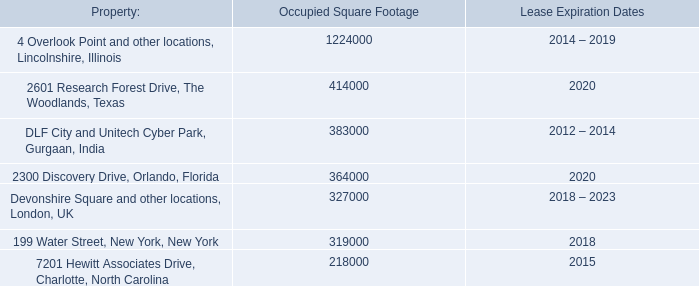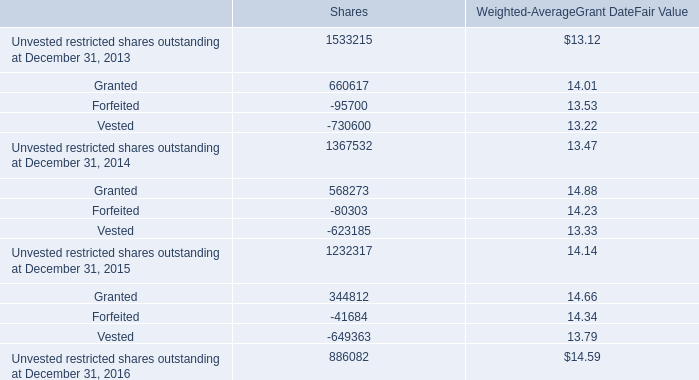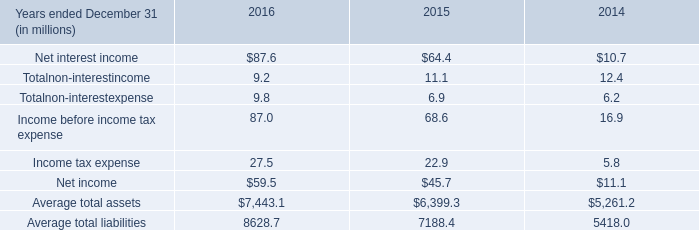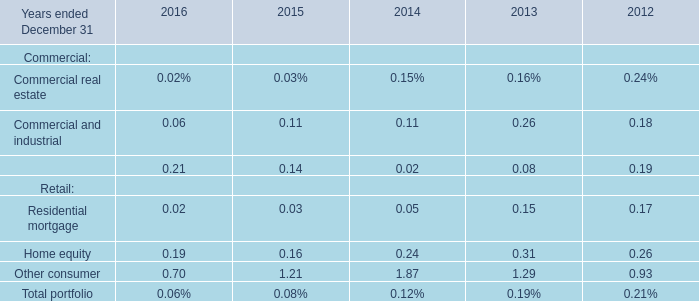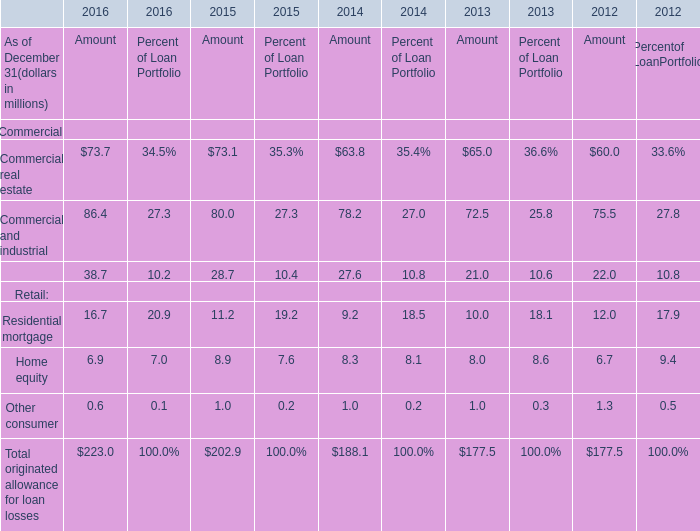In which year is Commercial and industrial for Amount greater than 79? 
Answer: 2015 2016. 